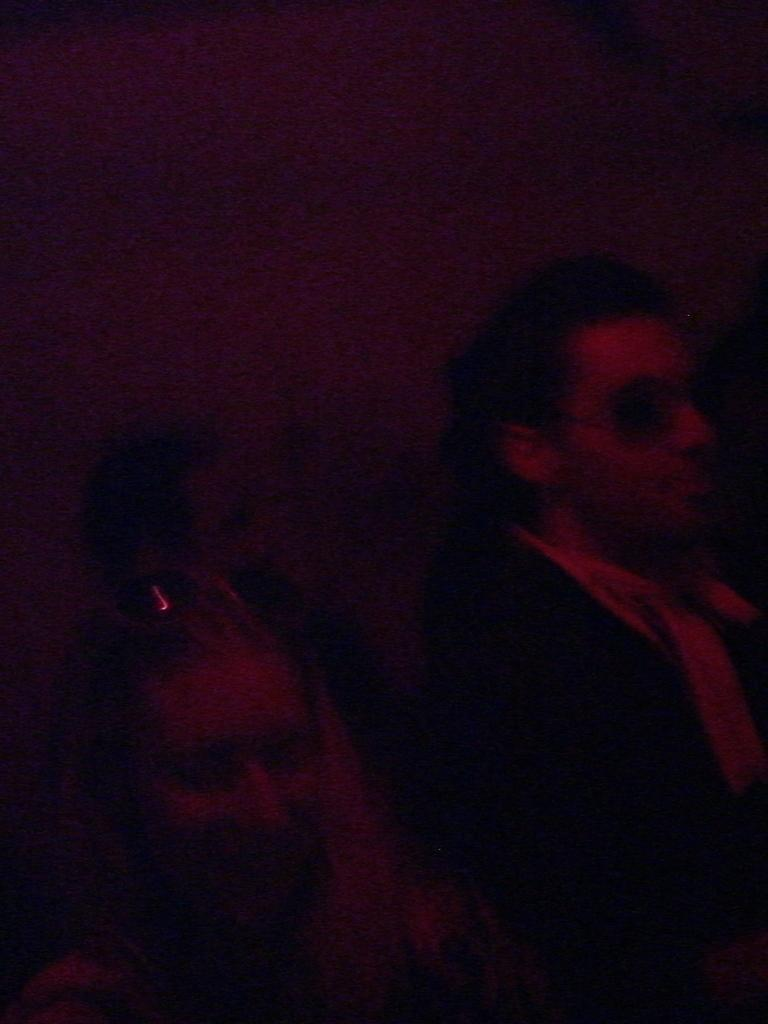How many people are visible in the image? There are three people visible in the image. Can you describe the positioning of the people in the image? There are two people in the foreground and another person behind them. What type of cherry is being used as a hat by the person in the foreground? There is no cherry present in the image, and no one is wearing a hat. 